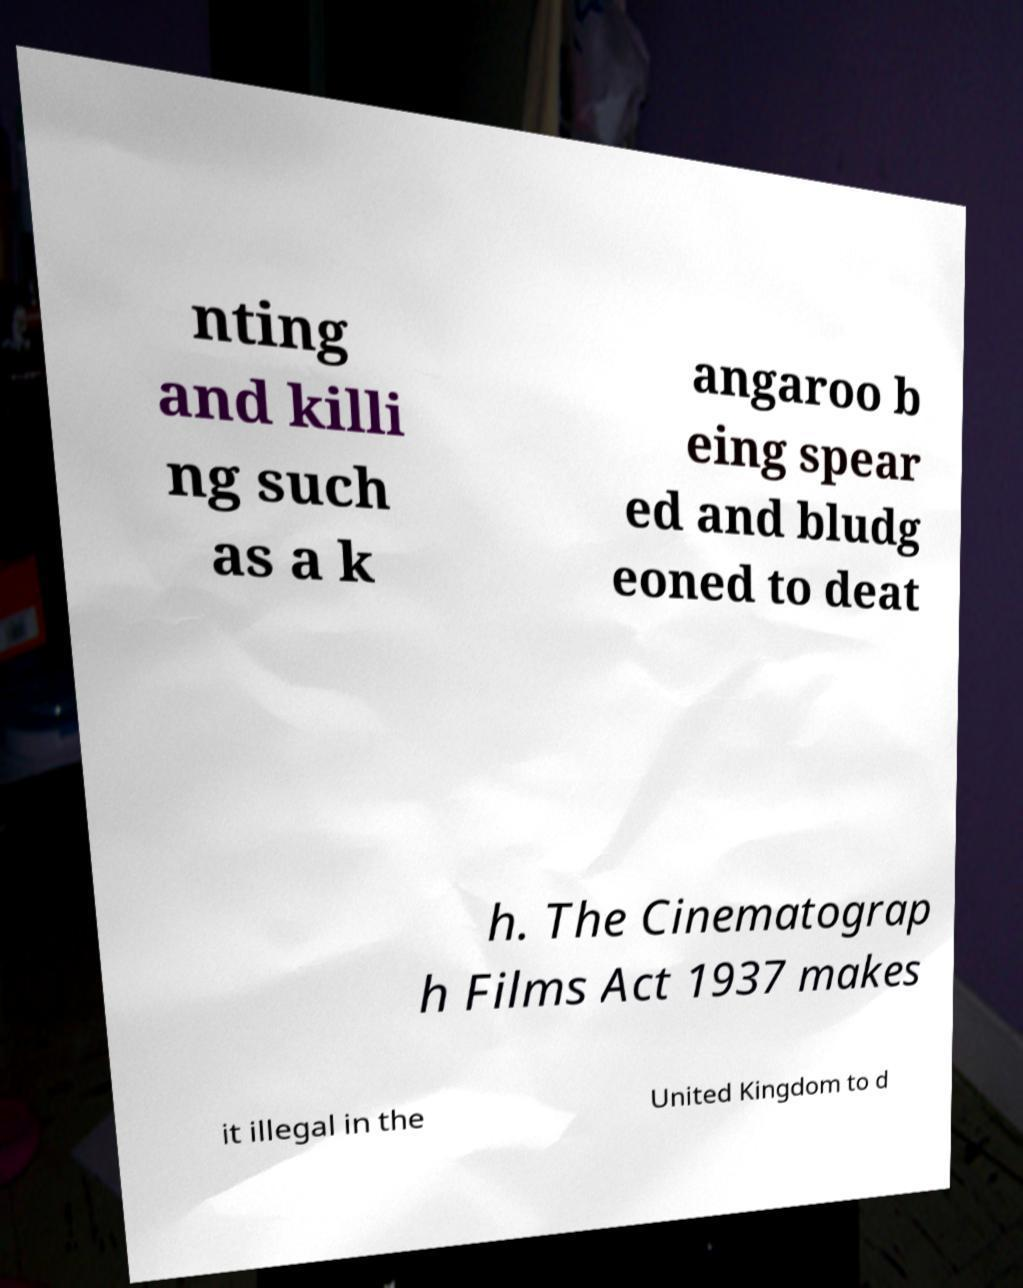Could you assist in decoding the text presented in this image and type it out clearly? nting and killi ng such as a k angaroo b eing spear ed and bludg eoned to deat h. The Cinematograp h Films Act 1937 makes it illegal in the United Kingdom to d 